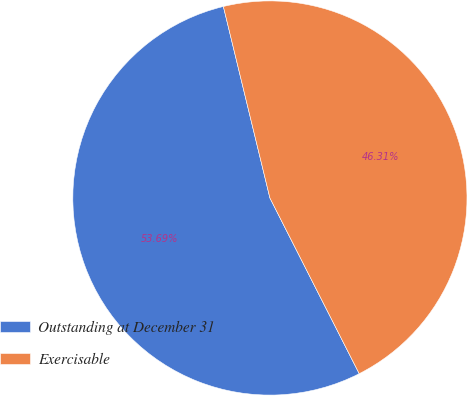Convert chart to OTSL. <chart><loc_0><loc_0><loc_500><loc_500><pie_chart><fcel>Outstanding at December 31<fcel>Exercisable<nl><fcel>53.69%<fcel>46.31%<nl></chart> 